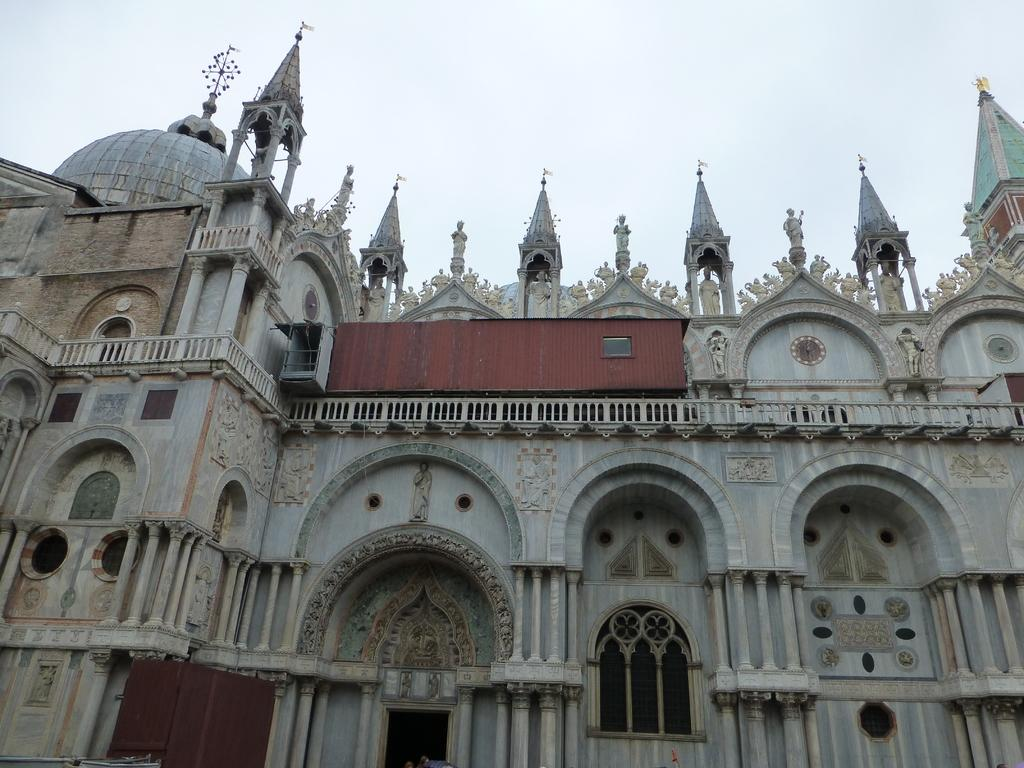What type of structure is present in the image? There is a building in the image. What decorative elements can be seen on the building? There are sculptures on the building. What is visible at the top of the image? The sky is visible at the top of the image. What type of toy can be seen flying in the image? There is no toy present in the image, let alone one that is flying. 